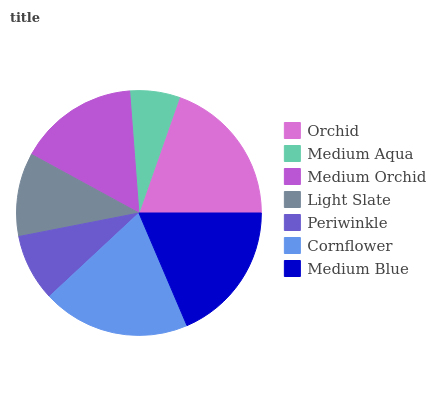Is Medium Aqua the minimum?
Answer yes or no. Yes. Is Orchid the maximum?
Answer yes or no. Yes. Is Medium Orchid the minimum?
Answer yes or no. No. Is Medium Orchid the maximum?
Answer yes or no. No. Is Medium Orchid greater than Medium Aqua?
Answer yes or no. Yes. Is Medium Aqua less than Medium Orchid?
Answer yes or no. Yes. Is Medium Aqua greater than Medium Orchid?
Answer yes or no. No. Is Medium Orchid less than Medium Aqua?
Answer yes or no. No. Is Medium Orchid the high median?
Answer yes or no. Yes. Is Medium Orchid the low median?
Answer yes or no. Yes. Is Periwinkle the high median?
Answer yes or no. No. Is Cornflower the low median?
Answer yes or no. No. 